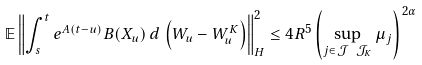Convert formula to latex. <formula><loc_0><loc_0><loc_500><loc_500>\mathbb { E } \left \| \int _ { s } ^ { t } e ^ { A ( t - u ) } B ( X _ { u } ) \, d \, \left ( W _ { u } - W ^ { K } _ { u } \right ) \right \| _ { H } ^ { 2 } \leq 4 R ^ { 5 } \left ( \sup _ { j \in \mathcal { J } \ \mathcal { J } _ { K } } \mu _ { j } \right ) ^ { \, 2 \alpha }</formula> 